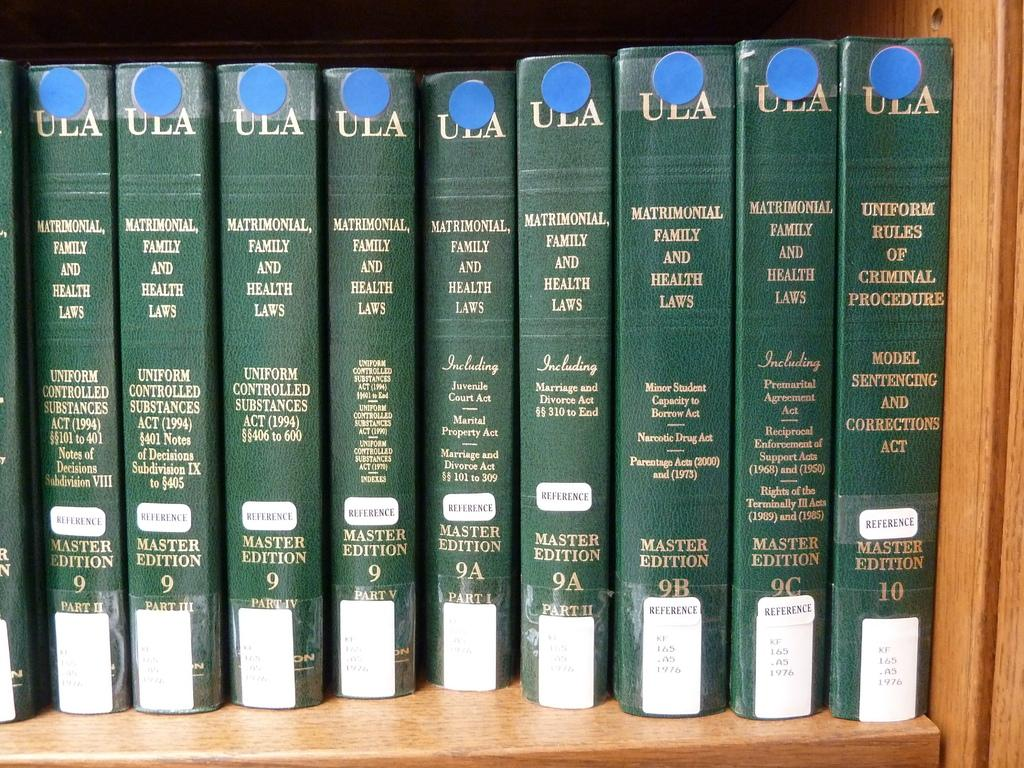<image>
Provide a brief description of the given image. "Matrimonial, Family and Health Laws" Master Edition can be found in the Reference Section. 